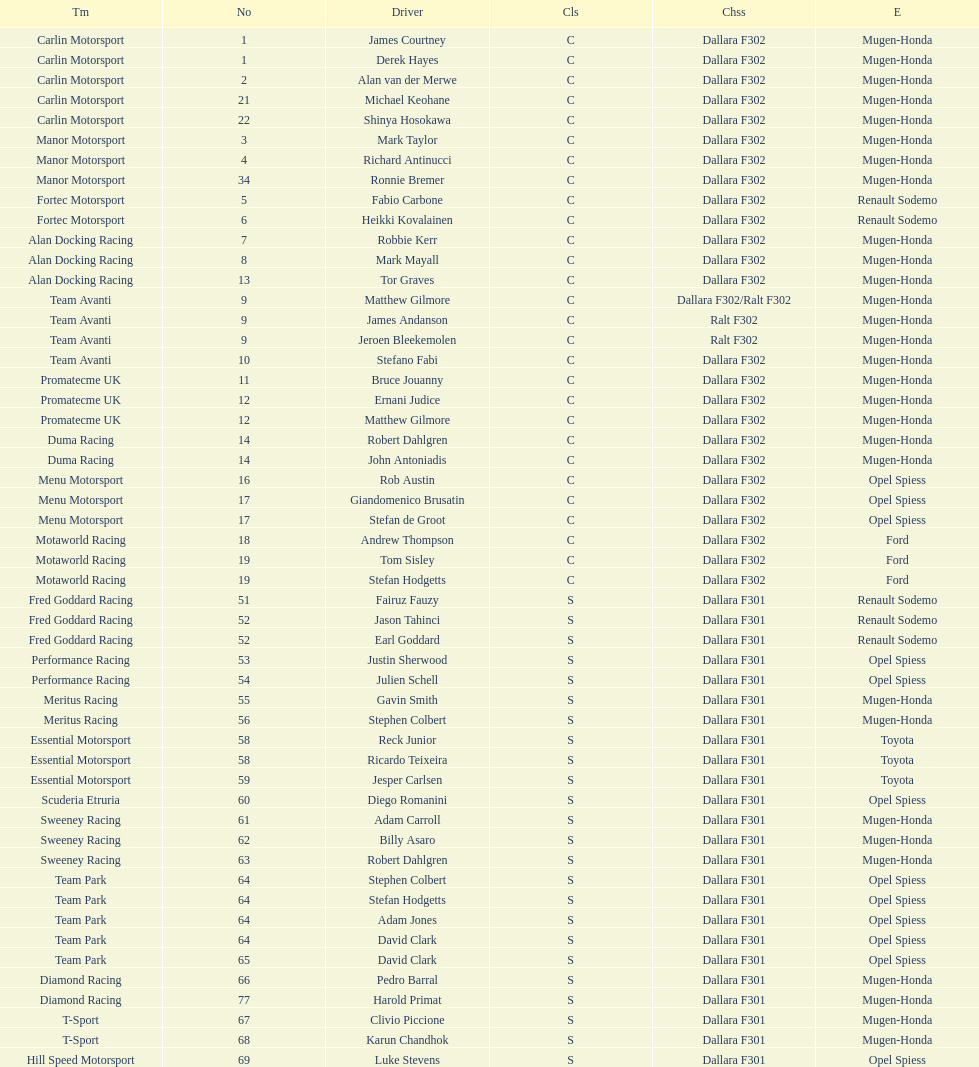What is the number of teams that had drivers all from the same country? 4. 